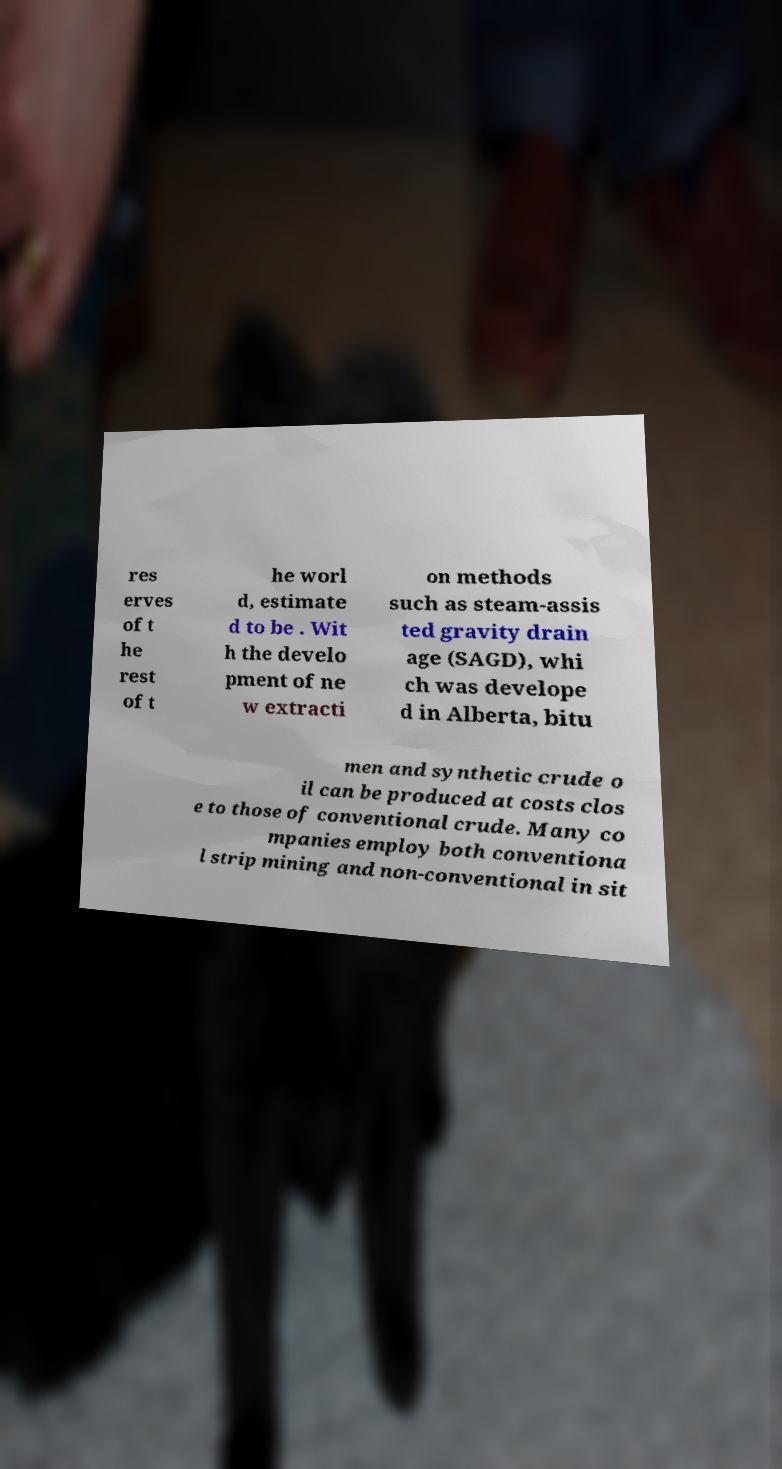For documentation purposes, I need the text within this image transcribed. Could you provide that? res erves of t he rest of t he worl d, estimate d to be . Wit h the develo pment of ne w extracti on methods such as steam-assis ted gravity drain age (SAGD), whi ch was develope d in Alberta, bitu men and synthetic crude o il can be produced at costs clos e to those of conventional crude. Many co mpanies employ both conventiona l strip mining and non-conventional in sit 